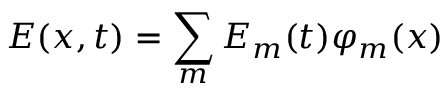<formula> <loc_0><loc_0><loc_500><loc_500>E ( x , t ) = \sum _ { m } E _ { m } ( t ) \varphi _ { m } ( x )</formula> 